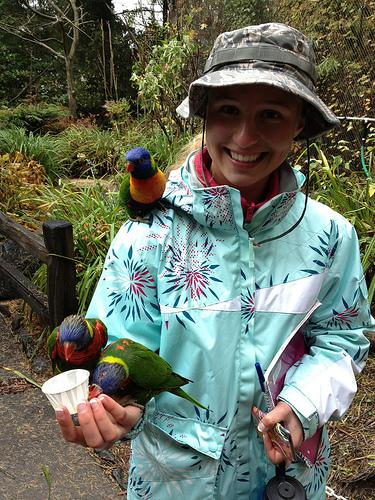Question: how is the photo?
Choices:
A. Faded.
B. Low angle shot.
C. Panaramic.
D. Clear.
Answer with the letter. Answer: D Question: who is this?
Choices:
A. Lady.
B. A neighbor.
C. The clerk.
D. The hostess.
Answer with the letter. Answer: A Question: where is this scene?
Choices:
A. At a school.
B. At a church.
C. In a park.
D. At a hospital.
Answer with the letter. Answer: C Question: what is she wearing?
Choices:
A. Gloves.
B. A sundress.
C. Hat.
D. High heels.
Answer with the letter. Answer: C Question: when is this?
Choices:
A. Nighttime.
B. Evening.
C. Daytime.
D. Morning.
Answer with the letter. Answer: C Question: why is she smiling?
Choices:
A. She is getting married.
B. He gave her flowers.
C. Happy.
D. She is having fun.
Answer with the letter. Answer: C 